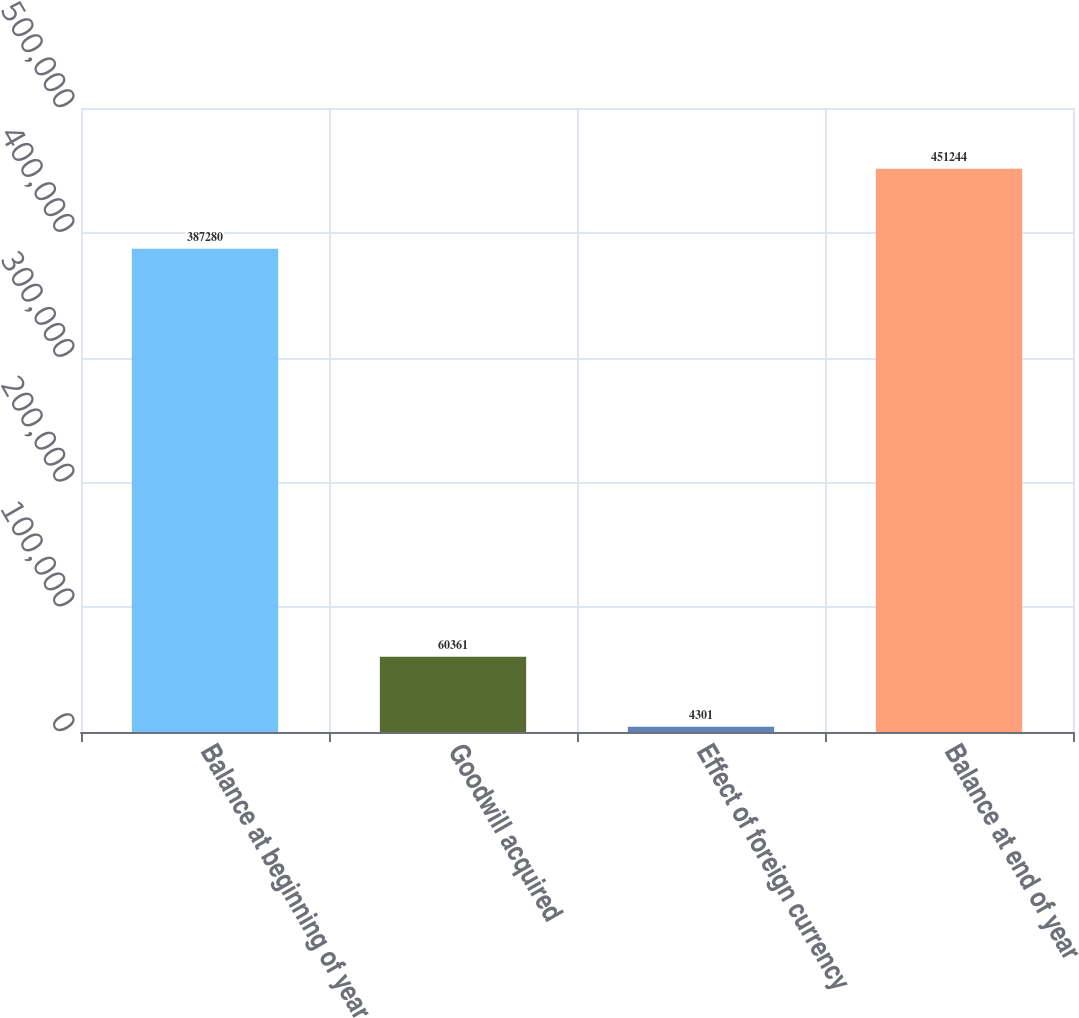<chart> <loc_0><loc_0><loc_500><loc_500><bar_chart><fcel>Balance at beginning of year<fcel>Goodwill acquired<fcel>Effect of foreign currency<fcel>Balance at end of year<nl><fcel>387280<fcel>60361<fcel>4301<fcel>451244<nl></chart> 